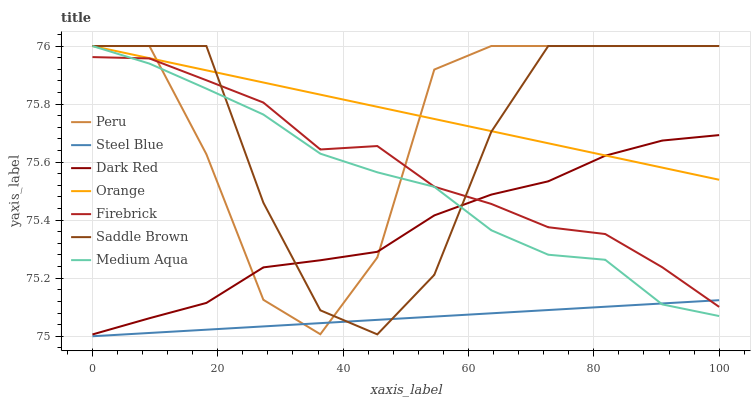Does Steel Blue have the minimum area under the curve?
Answer yes or no. Yes. Does Orange have the maximum area under the curve?
Answer yes or no. Yes. Does Firebrick have the minimum area under the curve?
Answer yes or no. No. Does Firebrick have the maximum area under the curve?
Answer yes or no. No. Is Orange the smoothest?
Answer yes or no. Yes. Is Peru the roughest?
Answer yes or no. Yes. Is Firebrick the smoothest?
Answer yes or no. No. Is Firebrick the roughest?
Answer yes or no. No. Does Steel Blue have the lowest value?
Answer yes or no. Yes. Does Firebrick have the lowest value?
Answer yes or no. No. Does Saddle Brown have the highest value?
Answer yes or no. Yes. Does Firebrick have the highest value?
Answer yes or no. No. Is Steel Blue less than Orange?
Answer yes or no. Yes. Is Orange greater than Steel Blue?
Answer yes or no. Yes. Does Dark Red intersect Peru?
Answer yes or no. Yes. Is Dark Red less than Peru?
Answer yes or no. No. Is Dark Red greater than Peru?
Answer yes or no. No. Does Steel Blue intersect Orange?
Answer yes or no. No. 